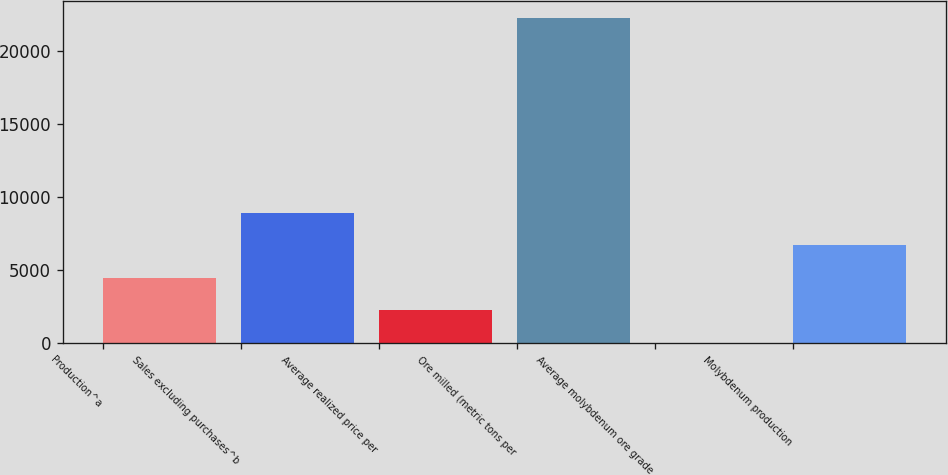Convert chart to OTSL. <chart><loc_0><loc_0><loc_500><loc_500><bar_chart><fcel>Production^a<fcel>Sales excluding purchases^b<fcel>Average realized price per<fcel>Ore milled (metric tons per<fcel>Average molybdenum ore grade<fcel>Molybdenum production<nl><fcel>4460.2<fcel>8920.16<fcel>2230.22<fcel>22300<fcel>0.24<fcel>6690.18<nl></chart> 